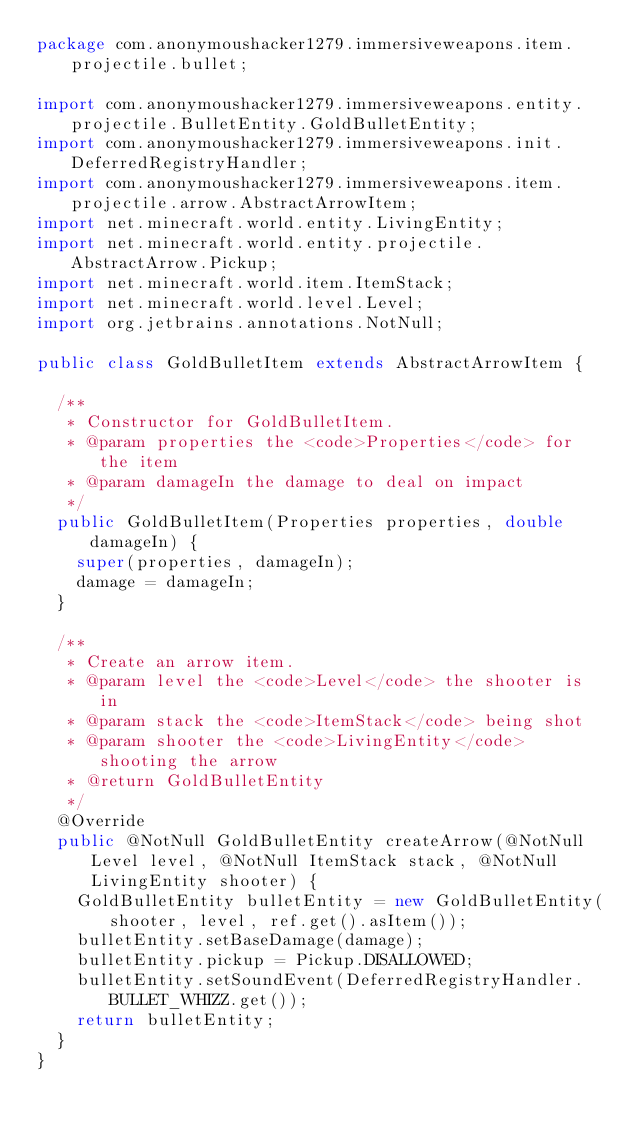<code> <loc_0><loc_0><loc_500><loc_500><_Java_>package com.anonymoushacker1279.immersiveweapons.item.projectile.bullet;

import com.anonymoushacker1279.immersiveweapons.entity.projectile.BulletEntity.GoldBulletEntity;
import com.anonymoushacker1279.immersiveweapons.init.DeferredRegistryHandler;
import com.anonymoushacker1279.immersiveweapons.item.projectile.arrow.AbstractArrowItem;
import net.minecraft.world.entity.LivingEntity;
import net.minecraft.world.entity.projectile.AbstractArrow.Pickup;
import net.minecraft.world.item.ItemStack;
import net.minecraft.world.level.Level;
import org.jetbrains.annotations.NotNull;

public class GoldBulletItem extends AbstractArrowItem {

	/**
	 * Constructor for GoldBulletItem.
	 * @param properties the <code>Properties</code> for the item
	 * @param damageIn the damage to deal on impact
	 */
	public GoldBulletItem(Properties properties, double damageIn) {
		super(properties, damageIn);
		damage = damageIn;
	}

	/**
	 * Create an arrow item.
	 * @param level the <code>Level</code> the shooter is in
	 * @param stack the <code>ItemStack</code> being shot
	 * @param shooter the <code>LivingEntity</code> shooting the arrow
	 * @return GoldBulletEntity
	 */
	@Override
	public @NotNull GoldBulletEntity createArrow(@NotNull Level level, @NotNull ItemStack stack, @NotNull LivingEntity shooter) {
		GoldBulletEntity bulletEntity = new GoldBulletEntity(shooter, level, ref.get().asItem());
		bulletEntity.setBaseDamage(damage);
		bulletEntity.pickup = Pickup.DISALLOWED;
		bulletEntity.setSoundEvent(DeferredRegistryHandler.BULLET_WHIZZ.get());
		return bulletEntity;
	}
}</code> 